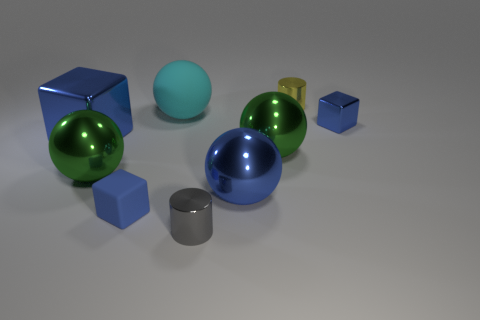Is the size of the rubber ball the same as the blue metallic ball? While it's difficult to determine the exact scale without a common reference, the rubber ball appears slightly smaller than the blue metallic ball based on observable perspective cues in the image. 